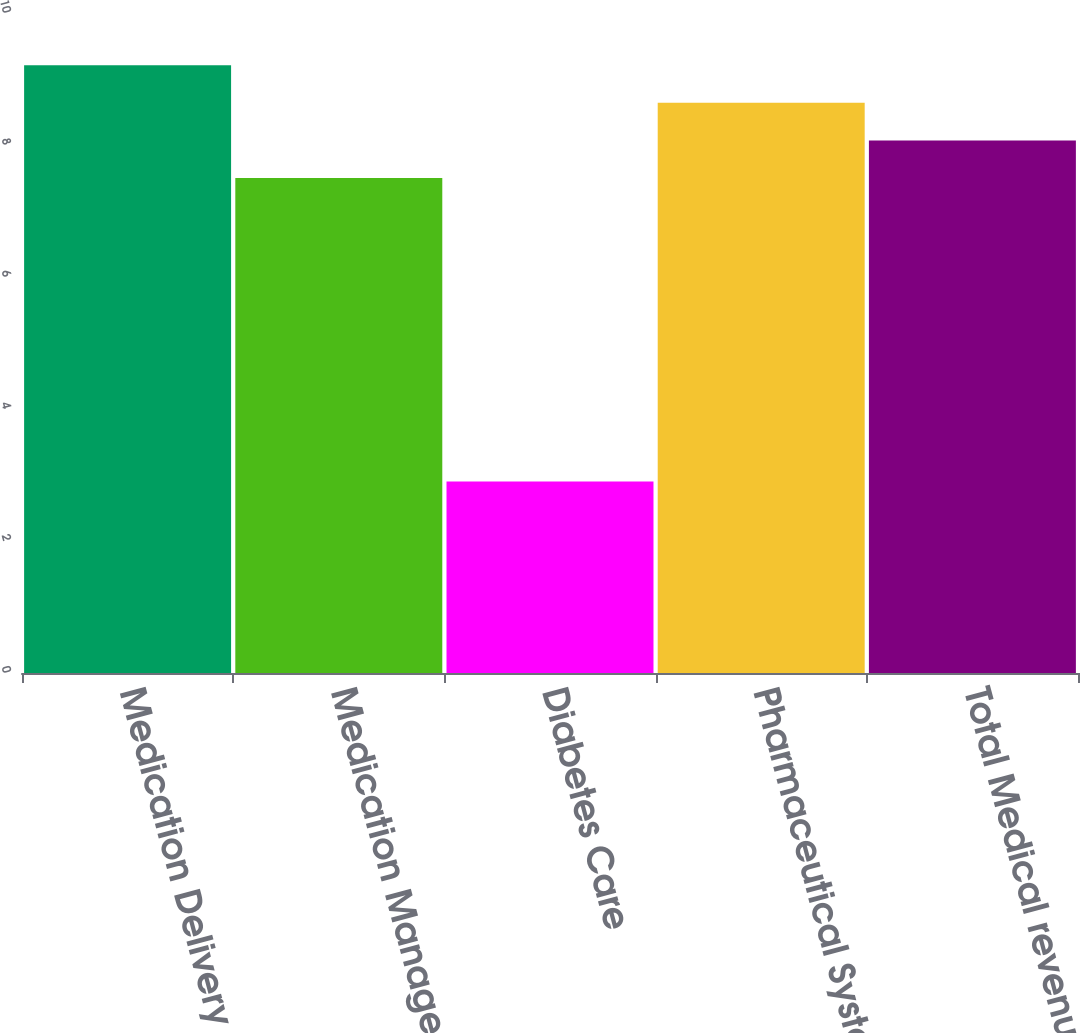Convert chart. <chart><loc_0><loc_0><loc_500><loc_500><bar_chart><fcel>Medication Delivery Solutions<fcel>Medication Management<fcel>Diabetes Care<fcel>Pharmaceutical Systems<fcel>Total Medical revenues<nl><fcel>9.21<fcel>7.5<fcel>2.9<fcel>8.64<fcel>8.07<nl></chart> 